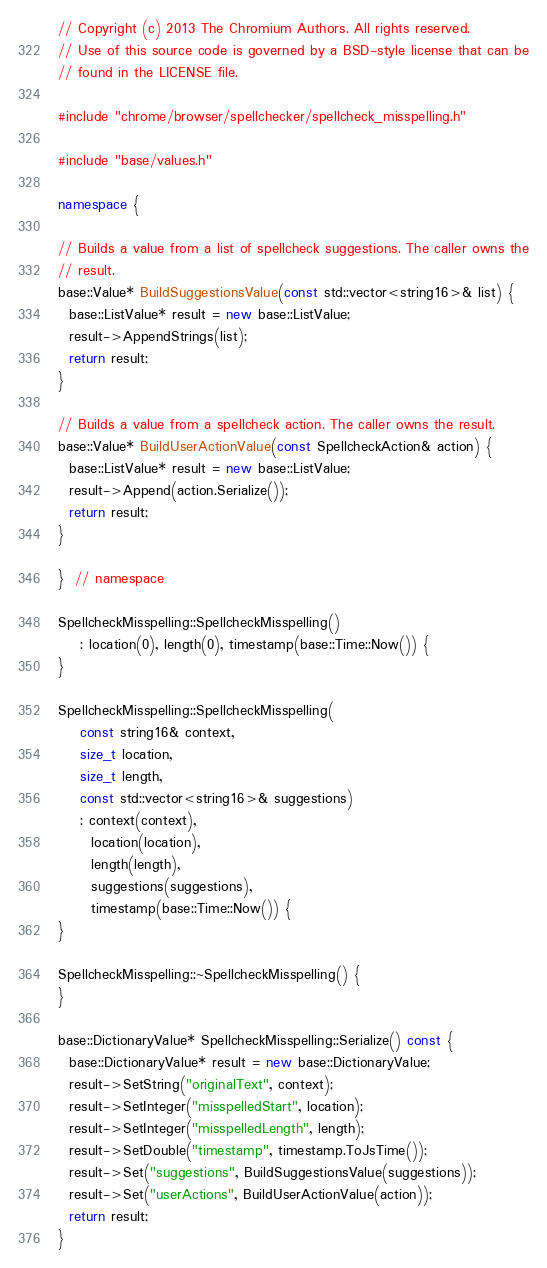<code> <loc_0><loc_0><loc_500><loc_500><_C++_>// Copyright (c) 2013 The Chromium Authors. All rights reserved.
// Use of this source code is governed by a BSD-style license that can be
// found in the LICENSE file.

#include "chrome/browser/spellchecker/spellcheck_misspelling.h"

#include "base/values.h"

namespace {

// Builds a value from a list of spellcheck suggestions. The caller owns the
// result.
base::Value* BuildSuggestionsValue(const std::vector<string16>& list) {
  base::ListValue* result = new base::ListValue;
  result->AppendStrings(list);
  return result;
}

// Builds a value from a spellcheck action. The caller owns the result.
base::Value* BuildUserActionValue(const SpellcheckAction& action) {
  base::ListValue* result = new base::ListValue;
  result->Append(action.Serialize());
  return result;
}

}  // namespace

SpellcheckMisspelling::SpellcheckMisspelling()
    : location(0), length(0), timestamp(base::Time::Now()) {
}

SpellcheckMisspelling::SpellcheckMisspelling(
    const string16& context,
    size_t location,
    size_t length,
    const std::vector<string16>& suggestions)
    : context(context),
      location(location),
      length(length),
      suggestions(suggestions),
      timestamp(base::Time::Now()) {
}

SpellcheckMisspelling::~SpellcheckMisspelling() {
}

base::DictionaryValue* SpellcheckMisspelling::Serialize() const {
  base::DictionaryValue* result = new base::DictionaryValue;
  result->SetString("originalText", context);
  result->SetInteger("misspelledStart", location);
  result->SetInteger("misspelledLength", length);
  result->SetDouble("timestamp", timestamp.ToJsTime());
  result->Set("suggestions", BuildSuggestionsValue(suggestions));
  result->Set("userActions", BuildUserActionValue(action));
  return result;
}
</code> 